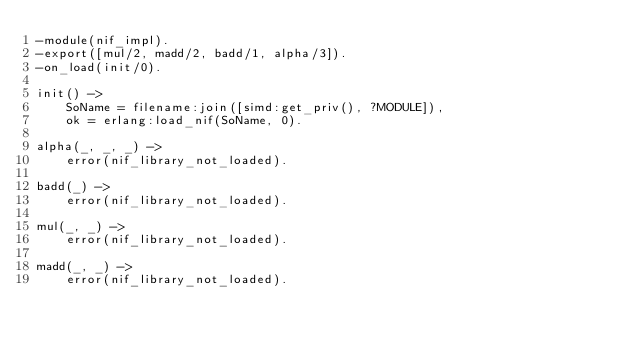Convert code to text. <code><loc_0><loc_0><loc_500><loc_500><_Erlang_>-module(nif_impl).
-export([mul/2, madd/2, badd/1, alpha/3]).
-on_load(init/0).

init() ->
    SoName = filename:join([simd:get_priv(), ?MODULE]),
    ok = erlang:load_nif(SoName, 0).

alpha(_, _, _) ->
    error(nif_library_not_loaded).

badd(_) ->
    error(nif_library_not_loaded).

mul(_, _) ->
    error(nif_library_not_loaded).

madd(_, _) ->
    error(nif_library_not_loaded).
</code> 